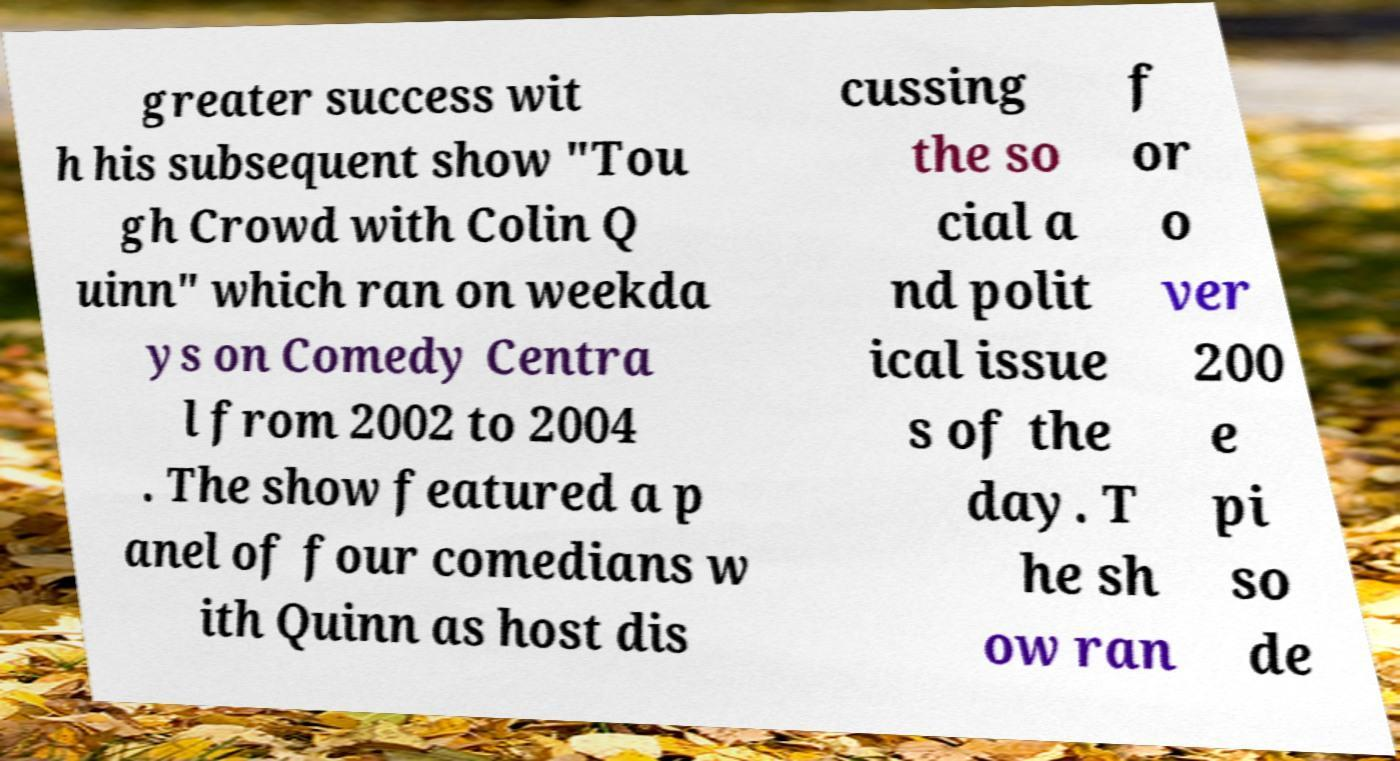Can you accurately transcribe the text from the provided image for me? greater success wit h his subsequent show "Tou gh Crowd with Colin Q uinn" which ran on weekda ys on Comedy Centra l from 2002 to 2004 . The show featured a p anel of four comedians w ith Quinn as host dis cussing the so cial a nd polit ical issue s of the day. T he sh ow ran f or o ver 200 e pi so de 